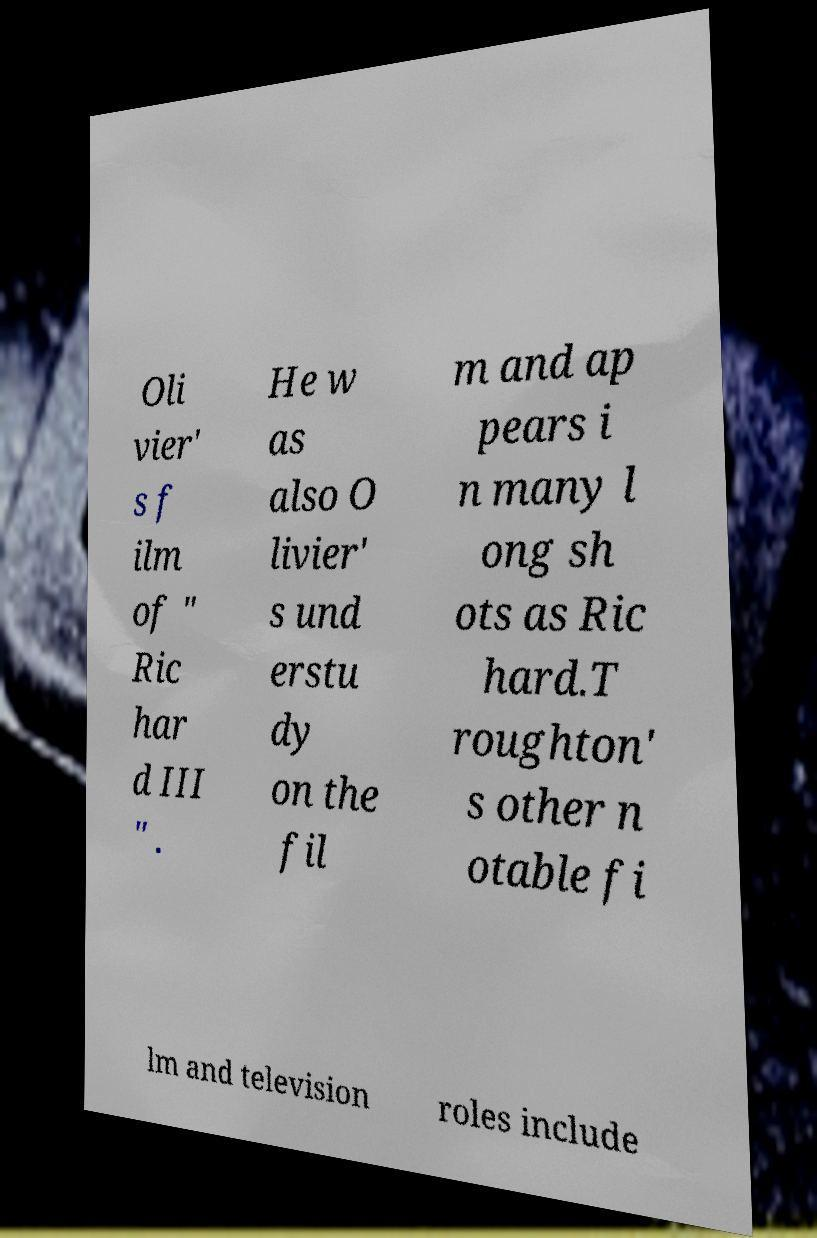I need the written content from this picture converted into text. Can you do that? Oli vier' s f ilm of " Ric har d III " . He w as also O livier' s und erstu dy on the fil m and ap pears i n many l ong sh ots as Ric hard.T roughton' s other n otable fi lm and television roles include 